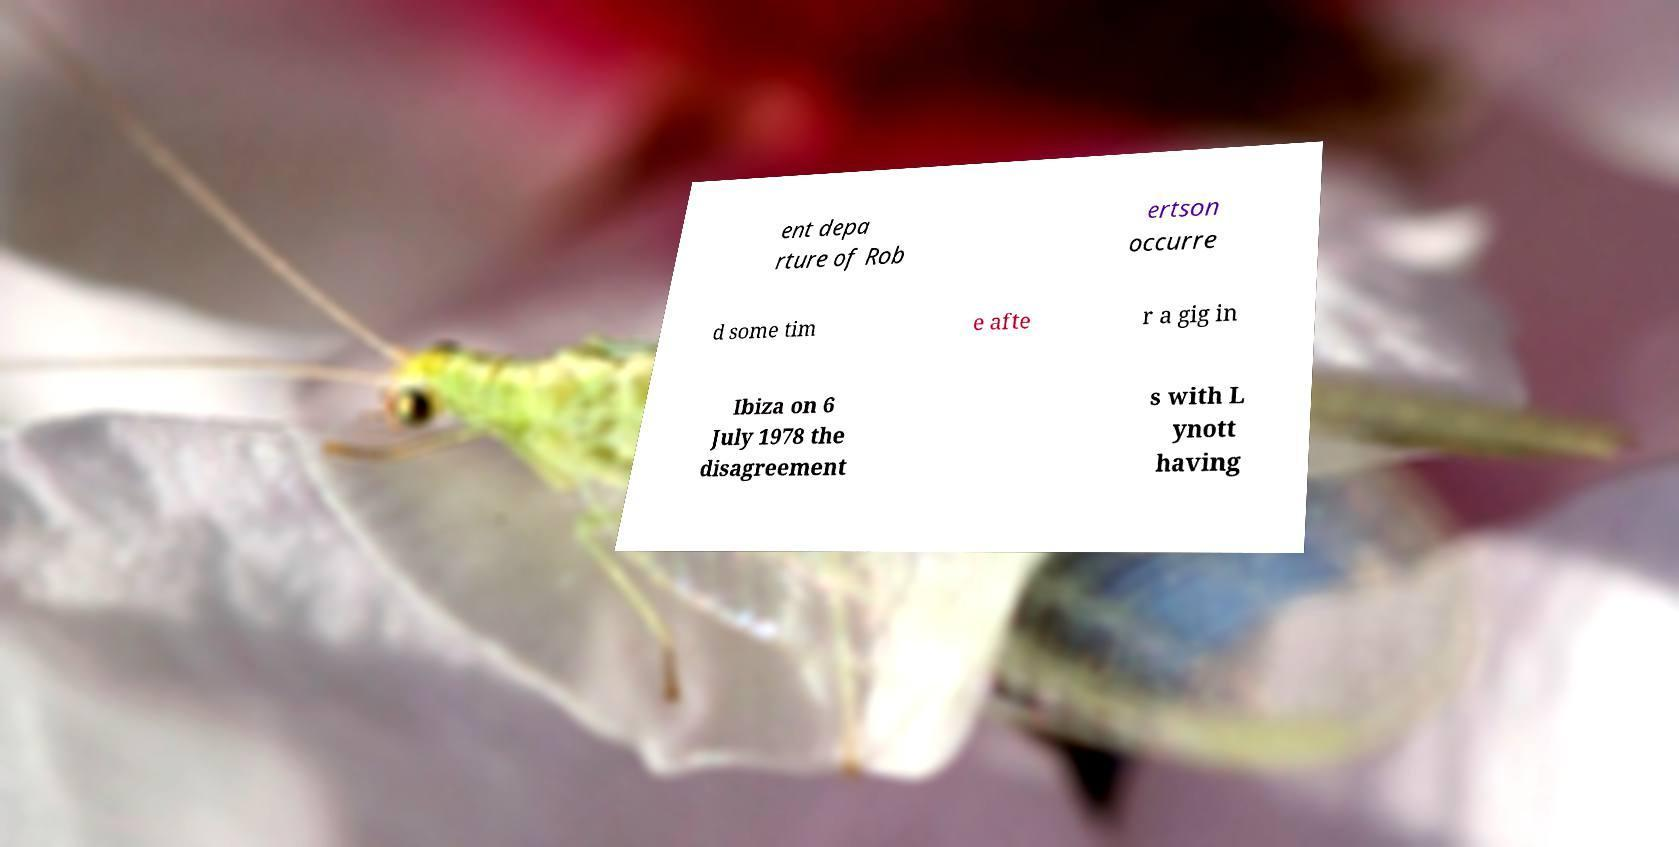Could you assist in decoding the text presented in this image and type it out clearly? ent depa rture of Rob ertson occurre d some tim e afte r a gig in Ibiza on 6 July 1978 the disagreement s with L ynott having 